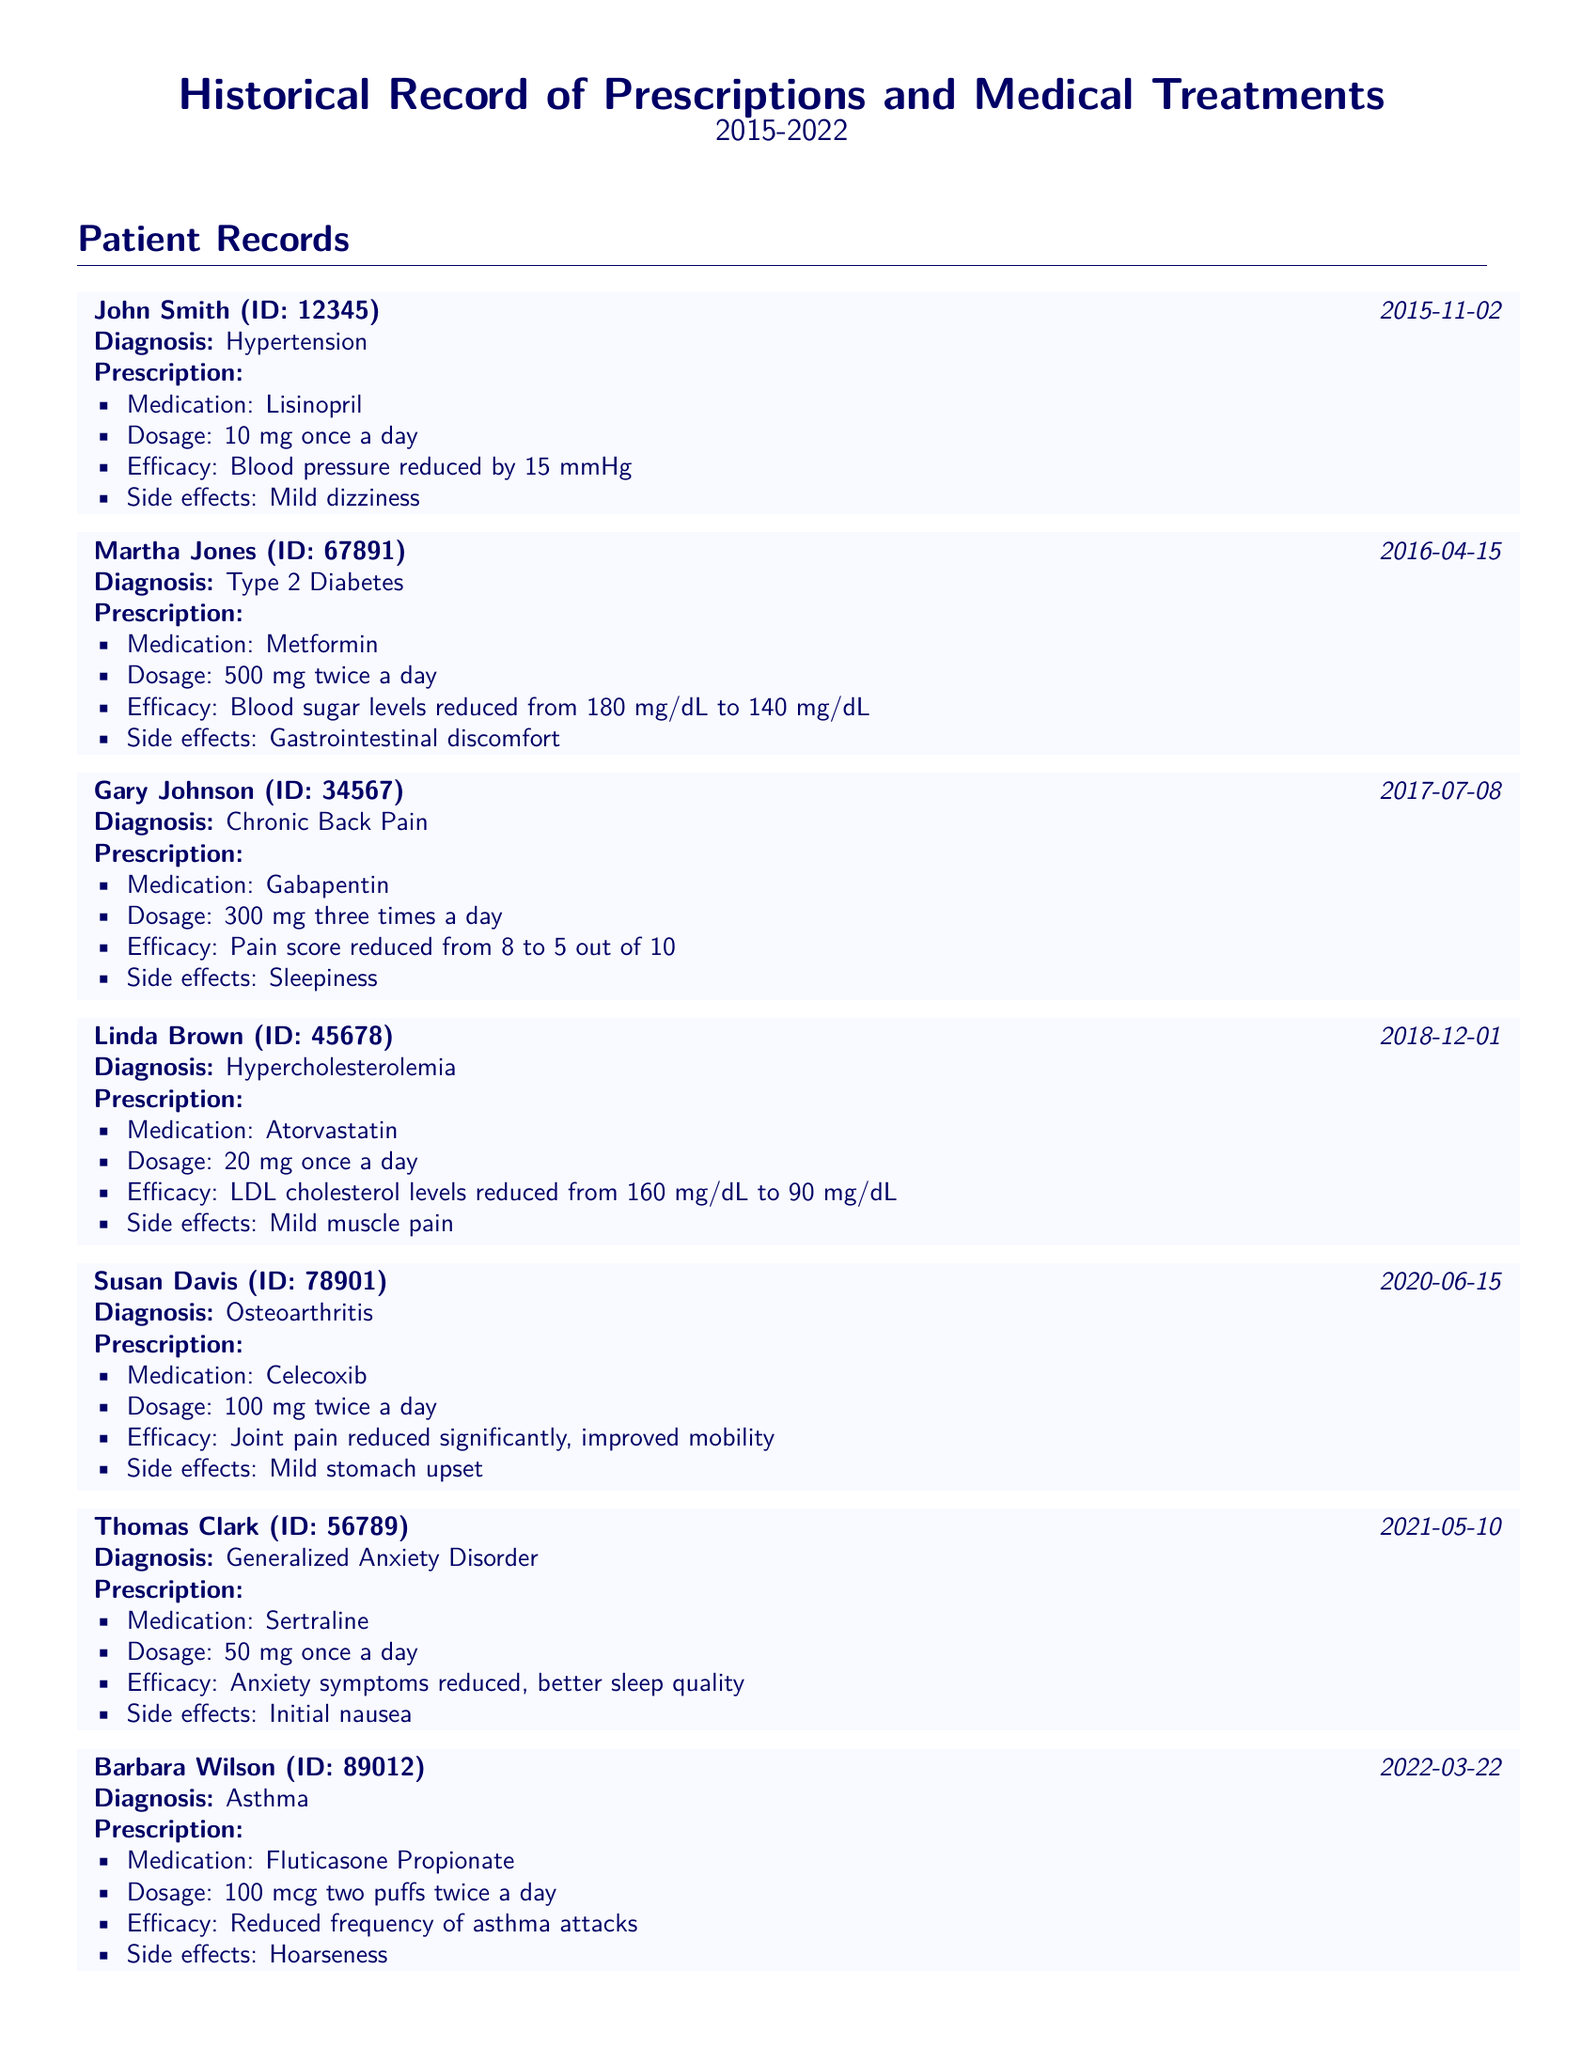What medication was prescribed for John Smith? The document lists the medication Lisinopril as prescribed for John Smith for hypertension.
Answer: Lisinopril What was the dosage of Metformin for Martha Jones? The document states that Martha Jones was prescribed Metformin at a dosage of 500 mg twice a day.
Answer: 500 mg twice a day What condition was Gary Johnson diagnosed with? According to the document, Gary Johnson was diagnosed with Chronic Back Pain.
Answer: Chronic Back Pain How much did LDL cholesterol reduce in Linda Brown? The document indicates that Linda Brown's LDL cholesterol levels reduced from 160 mg/dL to 90 mg/dL.
Answer: Reduced from 160 mg/dL to 90 mg/dL What side effect did Susan Davis experience from Celecoxib? The document specifies that Susan Davis experienced mild stomach upset as a side effect of Celecoxib.
Answer: Mild stomach upset What efficacy outcome is associated with Sertraline for Thomas Clark? The document notes that anxiety symptoms were reduced and sleep quality improved for Thomas Clark with Sertraline.
Answer: Anxiety symptoms reduced, better sleep quality Which patient was prescribed Fluticasone Propionate? The document states that Barbara Wilson was prescribed Fluticasone Propionate for asthma.
Answer: Barbara Wilson What year was Lisinopril prescribed? The document shows that Lisinopril was prescribed to John Smith on November 2, 2015.
Answer: 2015 What is the common condition treated with Atorvastatin? The document states that Atorvastatin is commonly used to treat Hypercholesterolemia as noted for Linda Brown.
Answer: Hypercholesterolemia 